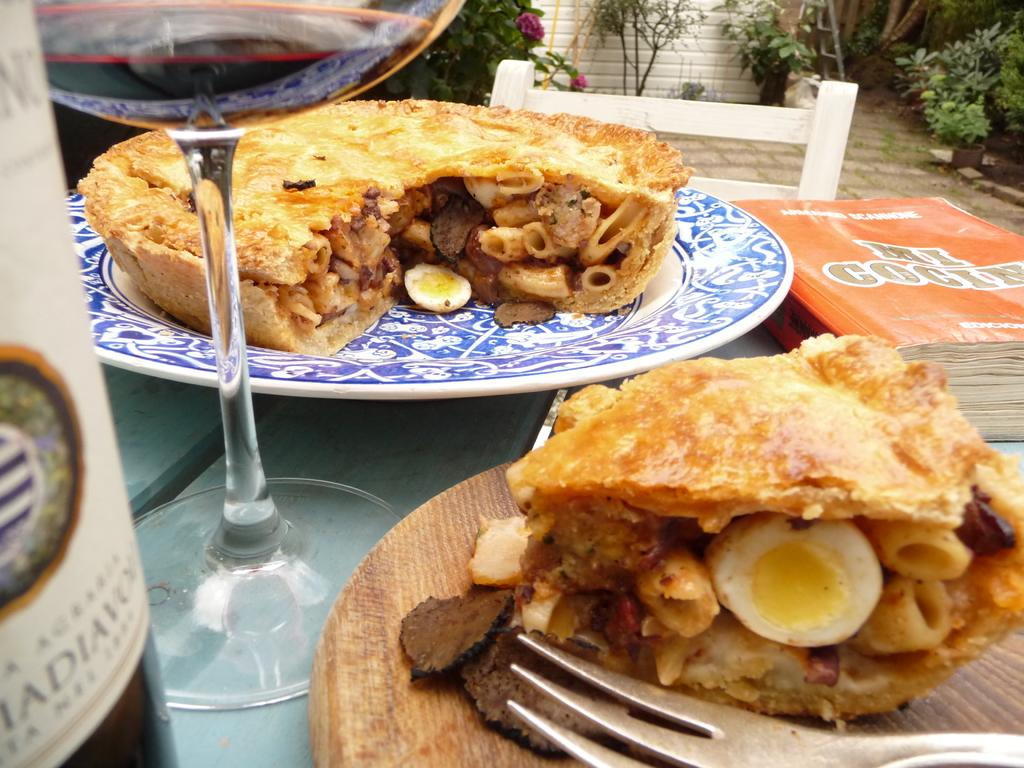What is on the plate in the image? There is a food item on a plate in the image. What type of glass is visible in the image? There is a wine glass in the image. What type of furniture is in the image? There is a sitting chair in the image. What piece of furniture is the plate and wine glass placed on? There is a table in the image. What type of decorative items are present in the image? There are plant pots in the image. What utensil is visible in the image? There is a fork in the image. What type of roof can be seen in the image? There is no roof visible in the image. How does the sail affect the food item on the plate? There is no sail present in the image, so it cannot affect the food item on the plate. 